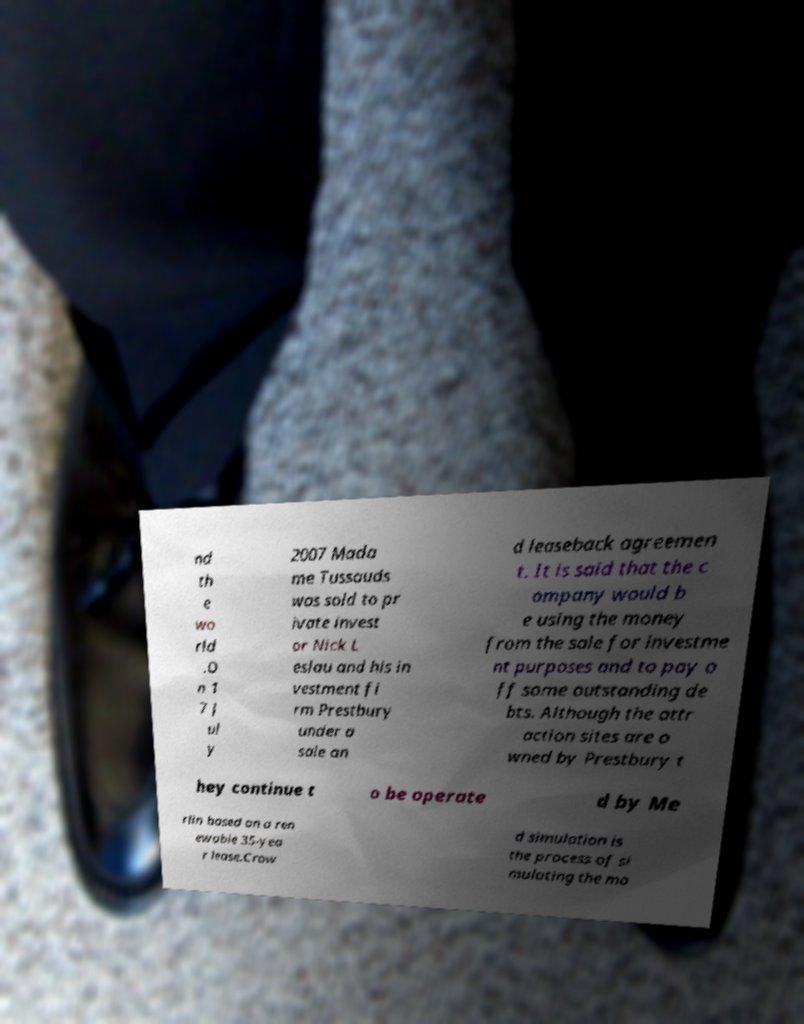Could you assist in decoding the text presented in this image and type it out clearly? nd th e wo rld .O n 1 7 J ul y 2007 Mada me Tussauds was sold to pr ivate invest or Nick L eslau and his in vestment fi rm Prestbury under a sale an d leaseback agreemen t. It is said that the c ompany would b e using the money from the sale for investme nt purposes and to pay o ff some outstanding de bts. Although the attr action sites are o wned by Prestbury t hey continue t o be operate d by Me rlin based on a ren ewable 35-yea r lease.Crow d simulation is the process of si mulating the mo 